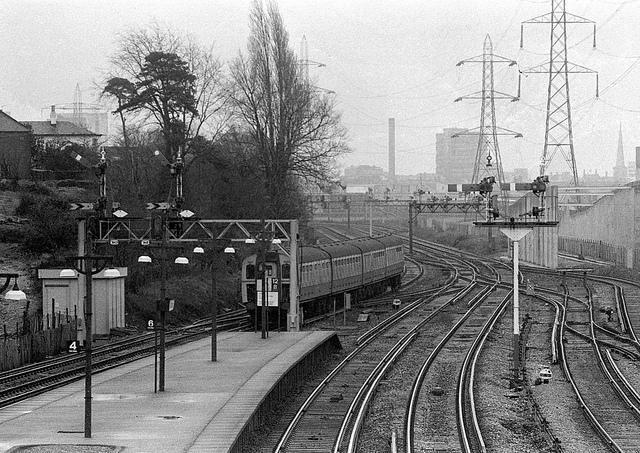How many power poles are off in the distance?
Give a very brief answer. 2. How many trains are on the track?
Give a very brief answer. 1. 